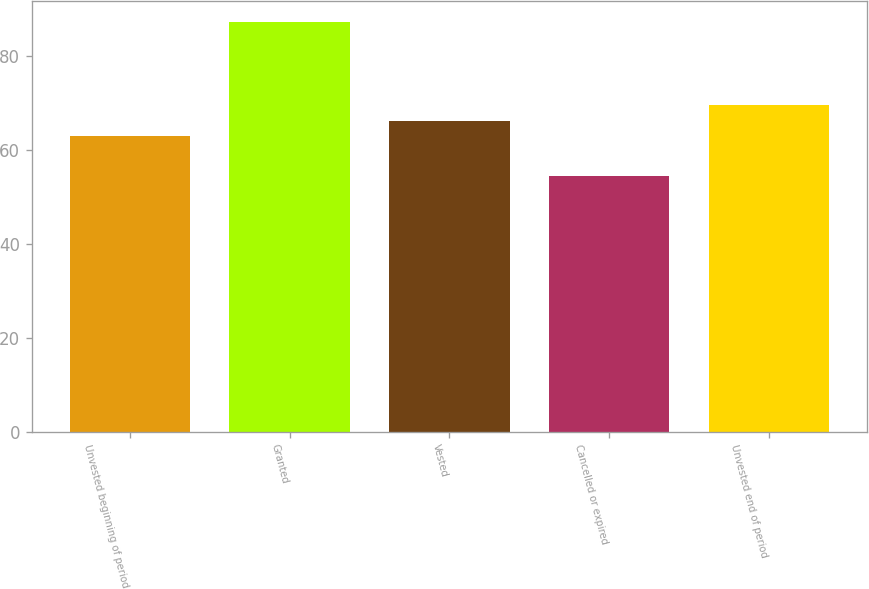Convert chart. <chart><loc_0><loc_0><loc_500><loc_500><bar_chart><fcel>Unvested beginning of period<fcel>Granted<fcel>Vested<fcel>Cancelled or expired<fcel>Unvested end of period<nl><fcel>62.85<fcel>87.18<fcel>66.12<fcel>54.48<fcel>69.39<nl></chart> 